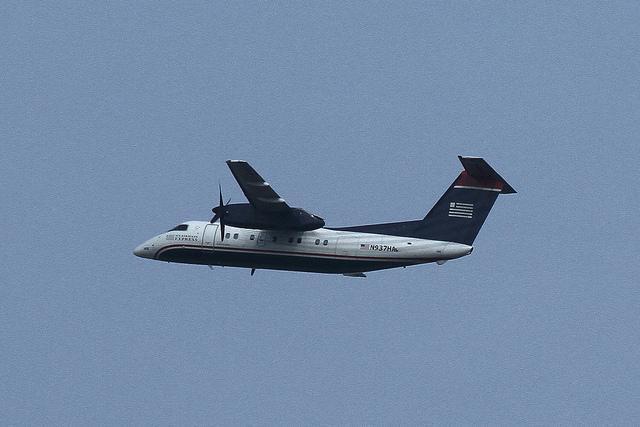How many planes can you see?
Give a very brief answer. 1. 